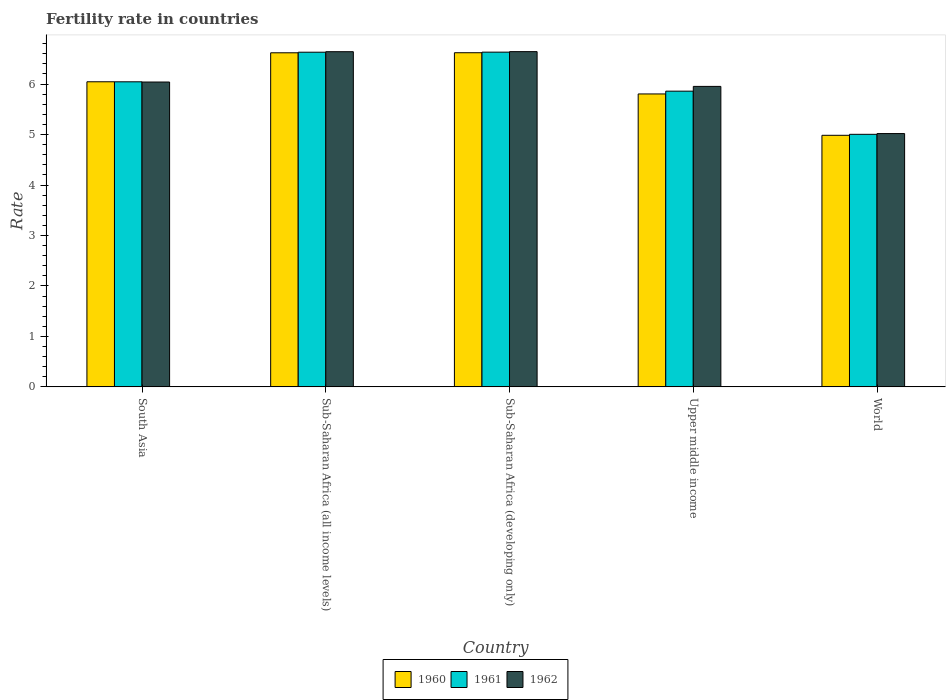How many groups of bars are there?
Give a very brief answer. 5. Are the number of bars per tick equal to the number of legend labels?
Your response must be concise. Yes. How many bars are there on the 4th tick from the right?
Your answer should be compact. 3. What is the label of the 4th group of bars from the left?
Your answer should be compact. Upper middle income. What is the fertility rate in 1960 in South Asia?
Give a very brief answer. 6.05. Across all countries, what is the maximum fertility rate in 1962?
Offer a terse response. 6.64. Across all countries, what is the minimum fertility rate in 1960?
Offer a terse response. 4.99. In which country was the fertility rate in 1962 maximum?
Keep it short and to the point. Sub-Saharan Africa (developing only). What is the total fertility rate in 1960 in the graph?
Your answer should be compact. 30.08. What is the difference between the fertility rate in 1960 in Sub-Saharan Africa (all income levels) and that in Upper middle income?
Offer a very short reply. 0.82. What is the difference between the fertility rate in 1961 in World and the fertility rate in 1962 in South Asia?
Provide a short and direct response. -1.04. What is the average fertility rate in 1960 per country?
Offer a terse response. 6.02. What is the difference between the fertility rate of/in 1961 and fertility rate of/in 1962 in Upper middle income?
Ensure brevity in your answer.  -0.09. What is the ratio of the fertility rate in 1961 in South Asia to that in Sub-Saharan Africa (developing only)?
Offer a terse response. 0.91. What is the difference between the highest and the second highest fertility rate in 1962?
Keep it short and to the point. -0.6. What is the difference between the highest and the lowest fertility rate in 1962?
Your response must be concise. 1.62. What does the 2nd bar from the left in Sub-Saharan Africa (all income levels) represents?
Your answer should be compact. 1961. How many bars are there?
Your answer should be very brief. 15. Are all the bars in the graph horizontal?
Ensure brevity in your answer.  No. How many countries are there in the graph?
Your response must be concise. 5. What is the difference between two consecutive major ticks on the Y-axis?
Your response must be concise. 1. Are the values on the major ticks of Y-axis written in scientific E-notation?
Keep it short and to the point. No. Does the graph contain any zero values?
Keep it short and to the point. No. Where does the legend appear in the graph?
Your response must be concise. Bottom center. How are the legend labels stacked?
Your response must be concise. Horizontal. What is the title of the graph?
Provide a succinct answer. Fertility rate in countries. Does "1977" appear as one of the legend labels in the graph?
Make the answer very short. No. What is the label or title of the X-axis?
Your answer should be compact. Country. What is the label or title of the Y-axis?
Your answer should be compact. Rate. What is the Rate in 1960 in South Asia?
Provide a succinct answer. 6.05. What is the Rate in 1961 in South Asia?
Ensure brevity in your answer.  6.05. What is the Rate in 1962 in South Asia?
Keep it short and to the point. 6.04. What is the Rate of 1960 in Sub-Saharan Africa (all income levels)?
Ensure brevity in your answer.  6.62. What is the Rate of 1961 in Sub-Saharan Africa (all income levels)?
Your response must be concise. 6.63. What is the Rate in 1962 in Sub-Saharan Africa (all income levels)?
Ensure brevity in your answer.  6.64. What is the Rate of 1960 in Sub-Saharan Africa (developing only)?
Make the answer very short. 6.62. What is the Rate in 1961 in Sub-Saharan Africa (developing only)?
Keep it short and to the point. 6.63. What is the Rate in 1962 in Sub-Saharan Africa (developing only)?
Give a very brief answer. 6.64. What is the Rate of 1960 in Upper middle income?
Ensure brevity in your answer.  5.8. What is the Rate in 1961 in Upper middle income?
Make the answer very short. 5.86. What is the Rate in 1962 in Upper middle income?
Provide a short and direct response. 5.95. What is the Rate of 1960 in World?
Keep it short and to the point. 4.99. What is the Rate in 1961 in World?
Give a very brief answer. 5. What is the Rate of 1962 in World?
Make the answer very short. 5.02. Across all countries, what is the maximum Rate of 1960?
Your answer should be very brief. 6.62. Across all countries, what is the maximum Rate of 1961?
Provide a short and direct response. 6.63. Across all countries, what is the maximum Rate of 1962?
Your answer should be very brief. 6.64. Across all countries, what is the minimum Rate in 1960?
Your answer should be compact. 4.99. Across all countries, what is the minimum Rate of 1961?
Your answer should be very brief. 5. Across all countries, what is the minimum Rate of 1962?
Make the answer very short. 5.02. What is the total Rate of 1960 in the graph?
Your answer should be compact. 30.08. What is the total Rate in 1961 in the graph?
Make the answer very short. 30.17. What is the total Rate of 1962 in the graph?
Make the answer very short. 30.3. What is the difference between the Rate in 1960 in South Asia and that in Sub-Saharan Africa (all income levels)?
Your answer should be very brief. -0.57. What is the difference between the Rate of 1961 in South Asia and that in Sub-Saharan Africa (all income levels)?
Give a very brief answer. -0.59. What is the difference between the Rate of 1962 in South Asia and that in Sub-Saharan Africa (all income levels)?
Provide a succinct answer. -0.6. What is the difference between the Rate of 1960 in South Asia and that in Sub-Saharan Africa (developing only)?
Make the answer very short. -0.58. What is the difference between the Rate of 1961 in South Asia and that in Sub-Saharan Africa (developing only)?
Ensure brevity in your answer.  -0.59. What is the difference between the Rate of 1962 in South Asia and that in Sub-Saharan Africa (developing only)?
Provide a short and direct response. -0.6. What is the difference between the Rate in 1960 in South Asia and that in Upper middle income?
Your answer should be very brief. 0.24. What is the difference between the Rate in 1961 in South Asia and that in Upper middle income?
Offer a very short reply. 0.19. What is the difference between the Rate of 1962 in South Asia and that in Upper middle income?
Provide a succinct answer. 0.09. What is the difference between the Rate in 1960 in South Asia and that in World?
Provide a short and direct response. 1.06. What is the difference between the Rate of 1961 in South Asia and that in World?
Provide a succinct answer. 1.04. What is the difference between the Rate of 1962 in South Asia and that in World?
Your answer should be very brief. 1.02. What is the difference between the Rate in 1960 in Sub-Saharan Africa (all income levels) and that in Sub-Saharan Africa (developing only)?
Give a very brief answer. -0. What is the difference between the Rate in 1961 in Sub-Saharan Africa (all income levels) and that in Sub-Saharan Africa (developing only)?
Provide a short and direct response. -0. What is the difference between the Rate in 1962 in Sub-Saharan Africa (all income levels) and that in Sub-Saharan Africa (developing only)?
Provide a short and direct response. -0. What is the difference between the Rate of 1960 in Sub-Saharan Africa (all income levels) and that in Upper middle income?
Give a very brief answer. 0.82. What is the difference between the Rate in 1961 in Sub-Saharan Africa (all income levels) and that in Upper middle income?
Make the answer very short. 0.77. What is the difference between the Rate in 1962 in Sub-Saharan Africa (all income levels) and that in Upper middle income?
Keep it short and to the point. 0.69. What is the difference between the Rate in 1960 in Sub-Saharan Africa (all income levels) and that in World?
Your response must be concise. 1.64. What is the difference between the Rate of 1961 in Sub-Saharan Africa (all income levels) and that in World?
Your answer should be very brief. 1.63. What is the difference between the Rate in 1962 in Sub-Saharan Africa (all income levels) and that in World?
Give a very brief answer. 1.62. What is the difference between the Rate of 1960 in Sub-Saharan Africa (developing only) and that in Upper middle income?
Offer a terse response. 0.82. What is the difference between the Rate in 1961 in Sub-Saharan Africa (developing only) and that in Upper middle income?
Your answer should be compact. 0.77. What is the difference between the Rate in 1962 in Sub-Saharan Africa (developing only) and that in Upper middle income?
Offer a terse response. 0.69. What is the difference between the Rate in 1960 in Sub-Saharan Africa (developing only) and that in World?
Give a very brief answer. 1.64. What is the difference between the Rate in 1961 in Sub-Saharan Africa (developing only) and that in World?
Give a very brief answer. 1.63. What is the difference between the Rate in 1962 in Sub-Saharan Africa (developing only) and that in World?
Your response must be concise. 1.62. What is the difference between the Rate of 1960 in Upper middle income and that in World?
Your response must be concise. 0.82. What is the difference between the Rate in 1961 in Upper middle income and that in World?
Offer a very short reply. 0.86. What is the difference between the Rate in 1962 in Upper middle income and that in World?
Provide a short and direct response. 0.93. What is the difference between the Rate of 1960 in South Asia and the Rate of 1961 in Sub-Saharan Africa (all income levels)?
Give a very brief answer. -0.59. What is the difference between the Rate in 1960 in South Asia and the Rate in 1962 in Sub-Saharan Africa (all income levels)?
Ensure brevity in your answer.  -0.6. What is the difference between the Rate of 1961 in South Asia and the Rate of 1962 in Sub-Saharan Africa (all income levels)?
Give a very brief answer. -0.6. What is the difference between the Rate in 1960 in South Asia and the Rate in 1961 in Sub-Saharan Africa (developing only)?
Offer a terse response. -0.59. What is the difference between the Rate of 1960 in South Asia and the Rate of 1962 in Sub-Saharan Africa (developing only)?
Make the answer very short. -0.6. What is the difference between the Rate of 1961 in South Asia and the Rate of 1962 in Sub-Saharan Africa (developing only)?
Offer a very short reply. -0.6. What is the difference between the Rate in 1960 in South Asia and the Rate in 1961 in Upper middle income?
Provide a succinct answer. 0.19. What is the difference between the Rate in 1960 in South Asia and the Rate in 1962 in Upper middle income?
Give a very brief answer. 0.09. What is the difference between the Rate of 1961 in South Asia and the Rate of 1962 in Upper middle income?
Make the answer very short. 0.09. What is the difference between the Rate in 1960 in South Asia and the Rate in 1961 in World?
Provide a succinct answer. 1.04. What is the difference between the Rate in 1960 in South Asia and the Rate in 1962 in World?
Your answer should be compact. 1.03. What is the difference between the Rate in 1961 in South Asia and the Rate in 1962 in World?
Keep it short and to the point. 1.03. What is the difference between the Rate in 1960 in Sub-Saharan Africa (all income levels) and the Rate in 1961 in Sub-Saharan Africa (developing only)?
Your answer should be very brief. -0.01. What is the difference between the Rate in 1960 in Sub-Saharan Africa (all income levels) and the Rate in 1962 in Sub-Saharan Africa (developing only)?
Provide a short and direct response. -0.02. What is the difference between the Rate in 1961 in Sub-Saharan Africa (all income levels) and the Rate in 1962 in Sub-Saharan Africa (developing only)?
Give a very brief answer. -0.01. What is the difference between the Rate of 1960 in Sub-Saharan Africa (all income levels) and the Rate of 1961 in Upper middle income?
Your answer should be very brief. 0.76. What is the difference between the Rate of 1960 in Sub-Saharan Africa (all income levels) and the Rate of 1962 in Upper middle income?
Give a very brief answer. 0.67. What is the difference between the Rate of 1961 in Sub-Saharan Africa (all income levels) and the Rate of 1962 in Upper middle income?
Your answer should be very brief. 0.68. What is the difference between the Rate in 1960 in Sub-Saharan Africa (all income levels) and the Rate in 1961 in World?
Offer a terse response. 1.62. What is the difference between the Rate in 1960 in Sub-Saharan Africa (all income levels) and the Rate in 1962 in World?
Your answer should be compact. 1.6. What is the difference between the Rate of 1961 in Sub-Saharan Africa (all income levels) and the Rate of 1962 in World?
Offer a terse response. 1.61. What is the difference between the Rate of 1960 in Sub-Saharan Africa (developing only) and the Rate of 1961 in Upper middle income?
Provide a short and direct response. 0.76. What is the difference between the Rate of 1960 in Sub-Saharan Africa (developing only) and the Rate of 1962 in Upper middle income?
Your answer should be very brief. 0.67. What is the difference between the Rate in 1961 in Sub-Saharan Africa (developing only) and the Rate in 1962 in Upper middle income?
Your answer should be very brief. 0.68. What is the difference between the Rate of 1960 in Sub-Saharan Africa (developing only) and the Rate of 1961 in World?
Make the answer very short. 1.62. What is the difference between the Rate in 1960 in Sub-Saharan Africa (developing only) and the Rate in 1962 in World?
Make the answer very short. 1.6. What is the difference between the Rate of 1961 in Sub-Saharan Africa (developing only) and the Rate of 1962 in World?
Give a very brief answer. 1.61. What is the difference between the Rate in 1960 in Upper middle income and the Rate in 1962 in World?
Ensure brevity in your answer.  0.79. What is the difference between the Rate in 1961 in Upper middle income and the Rate in 1962 in World?
Your answer should be compact. 0.84. What is the average Rate in 1960 per country?
Offer a terse response. 6.02. What is the average Rate of 1961 per country?
Provide a succinct answer. 6.03. What is the average Rate in 1962 per country?
Offer a terse response. 6.06. What is the difference between the Rate of 1960 and Rate of 1961 in South Asia?
Give a very brief answer. 0. What is the difference between the Rate in 1960 and Rate in 1962 in South Asia?
Your answer should be compact. 0. What is the difference between the Rate in 1961 and Rate in 1962 in South Asia?
Your response must be concise. 0. What is the difference between the Rate of 1960 and Rate of 1961 in Sub-Saharan Africa (all income levels)?
Your answer should be very brief. -0.01. What is the difference between the Rate in 1960 and Rate in 1962 in Sub-Saharan Africa (all income levels)?
Provide a succinct answer. -0.02. What is the difference between the Rate of 1961 and Rate of 1962 in Sub-Saharan Africa (all income levels)?
Your response must be concise. -0.01. What is the difference between the Rate of 1960 and Rate of 1961 in Sub-Saharan Africa (developing only)?
Your answer should be compact. -0.01. What is the difference between the Rate in 1960 and Rate in 1962 in Sub-Saharan Africa (developing only)?
Offer a terse response. -0.02. What is the difference between the Rate in 1961 and Rate in 1962 in Sub-Saharan Africa (developing only)?
Your response must be concise. -0.01. What is the difference between the Rate in 1960 and Rate in 1961 in Upper middle income?
Your answer should be compact. -0.06. What is the difference between the Rate of 1960 and Rate of 1962 in Upper middle income?
Your answer should be compact. -0.15. What is the difference between the Rate in 1961 and Rate in 1962 in Upper middle income?
Your answer should be compact. -0.09. What is the difference between the Rate of 1960 and Rate of 1961 in World?
Offer a terse response. -0.02. What is the difference between the Rate in 1960 and Rate in 1962 in World?
Provide a short and direct response. -0.03. What is the difference between the Rate of 1961 and Rate of 1962 in World?
Your response must be concise. -0.01. What is the ratio of the Rate of 1960 in South Asia to that in Sub-Saharan Africa (all income levels)?
Your answer should be very brief. 0.91. What is the ratio of the Rate in 1961 in South Asia to that in Sub-Saharan Africa (all income levels)?
Your answer should be compact. 0.91. What is the ratio of the Rate in 1962 in South Asia to that in Sub-Saharan Africa (all income levels)?
Give a very brief answer. 0.91. What is the ratio of the Rate in 1960 in South Asia to that in Sub-Saharan Africa (developing only)?
Give a very brief answer. 0.91. What is the ratio of the Rate of 1961 in South Asia to that in Sub-Saharan Africa (developing only)?
Make the answer very short. 0.91. What is the ratio of the Rate of 1962 in South Asia to that in Sub-Saharan Africa (developing only)?
Offer a terse response. 0.91. What is the ratio of the Rate in 1960 in South Asia to that in Upper middle income?
Your answer should be very brief. 1.04. What is the ratio of the Rate in 1961 in South Asia to that in Upper middle income?
Make the answer very short. 1.03. What is the ratio of the Rate of 1962 in South Asia to that in Upper middle income?
Make the answer very short. 1.01. What is the ratio of the Rate in 1960 in South Asia to that in World?
Offer a very short reply. 1.21. What is the ratio of the Rate in 1961 in South Asia to that in World?
Offer a terse response. 1.21. What is the ratio of the Rate of 1962 in South Asia to that in World?
Your answer should be compact. 1.2. What is the ratio of the Rate of 1962 in Sub-Saharan Africa (all income levels) to that in Sub-Saharan Africa (developing only)?
Offer a terse response. 1. What is the ratio of the Rate in 1960 in Sub-Saharan Africa (all income levels) to that in Upper middle income?
Provide a succinct answer. 1.14. What is the ratio of the Rate of 1961 in Sub-Saharan Africa (all income levels) to that in Upper middle income?
Your response must be concise. 1.13. What is the ratio of the Rate in 1962 in Sub-Saharan Africa (all income levels) to that in Upper middle income?
Your answer should be compact. 1.12. What is the ratio of the Rate in 1960 in Sub-Saharan Africa (all income levels) to that in World?
Keep it short and to the point. 1.33. What is the ratio of the Rate of 1961 in Sub-Saharan Africa (all income levels) to that in World?
Your answer should be very brief. 1.33. What is the ratio of the Rate of 1962 in Sub-Saharan Africa (all income levels) to that in World?
Your response must be concise. 1.32. What is the ratio of the Rate in 1960 in Sub-Saharan Africa (developing only) to that in Upper middle income?
Ensure brevity in your answer.  1.14. What is the ratio of the Rate in 1961 in Sub-Saharan Africa (developing only) to that in Upper middle income?
Make the answer very short. 1.13. What is the ratio of the Rate in 1962 in Sub-Saharan Africa (developing only) to that in Upper middle income?
Ensure brevity in your answer.  1.12. What is the ratio of the Rate in 1960 in Sub-Saharan Africa (developing only) to that in World?
Give a very brief answer. 1.33. What is the ratio of the Rate of 1961 in Sub-Saharan Africa (developing only) to that in World?
Your response must be concise. 1.33. What is the ratio of the Rate of 1962 in Sub-Saharan Africa (developing only) to that in World?
Your answer should be compact. 1.32. What is the ratio of the Rate of 1960 in Upper middle income to that in World?
Offer a terse response. 1.16. What is the ratio of the Rate in 1961 in Upper middle income to that in World?
Offer a very short reply. 1.17. What is the ratio of the Rate of 1962 in Upper middle income to that in World?
Offer a terse response. 1.19. What is the difference between the highest and the second highest Rate in 1960?
Your response must be concise. 0. What is the difference between the highest and the second highest Rate in 1961?
Your answer should be compact. 0. What is the difference between the highest and the second highest Rate of 1962?
Give a very brief answer. 0. What is the difference between the highest and the lowest Rate in 1960?
Offer a very short reply. 1.64. What is the difference between the highest and the lowest Rate of 1961?
Your answer should be very brief. 1.63. What is the difference between the highest and the lowest Rate of 1962?
Provide a succinct answer. 1.62. 